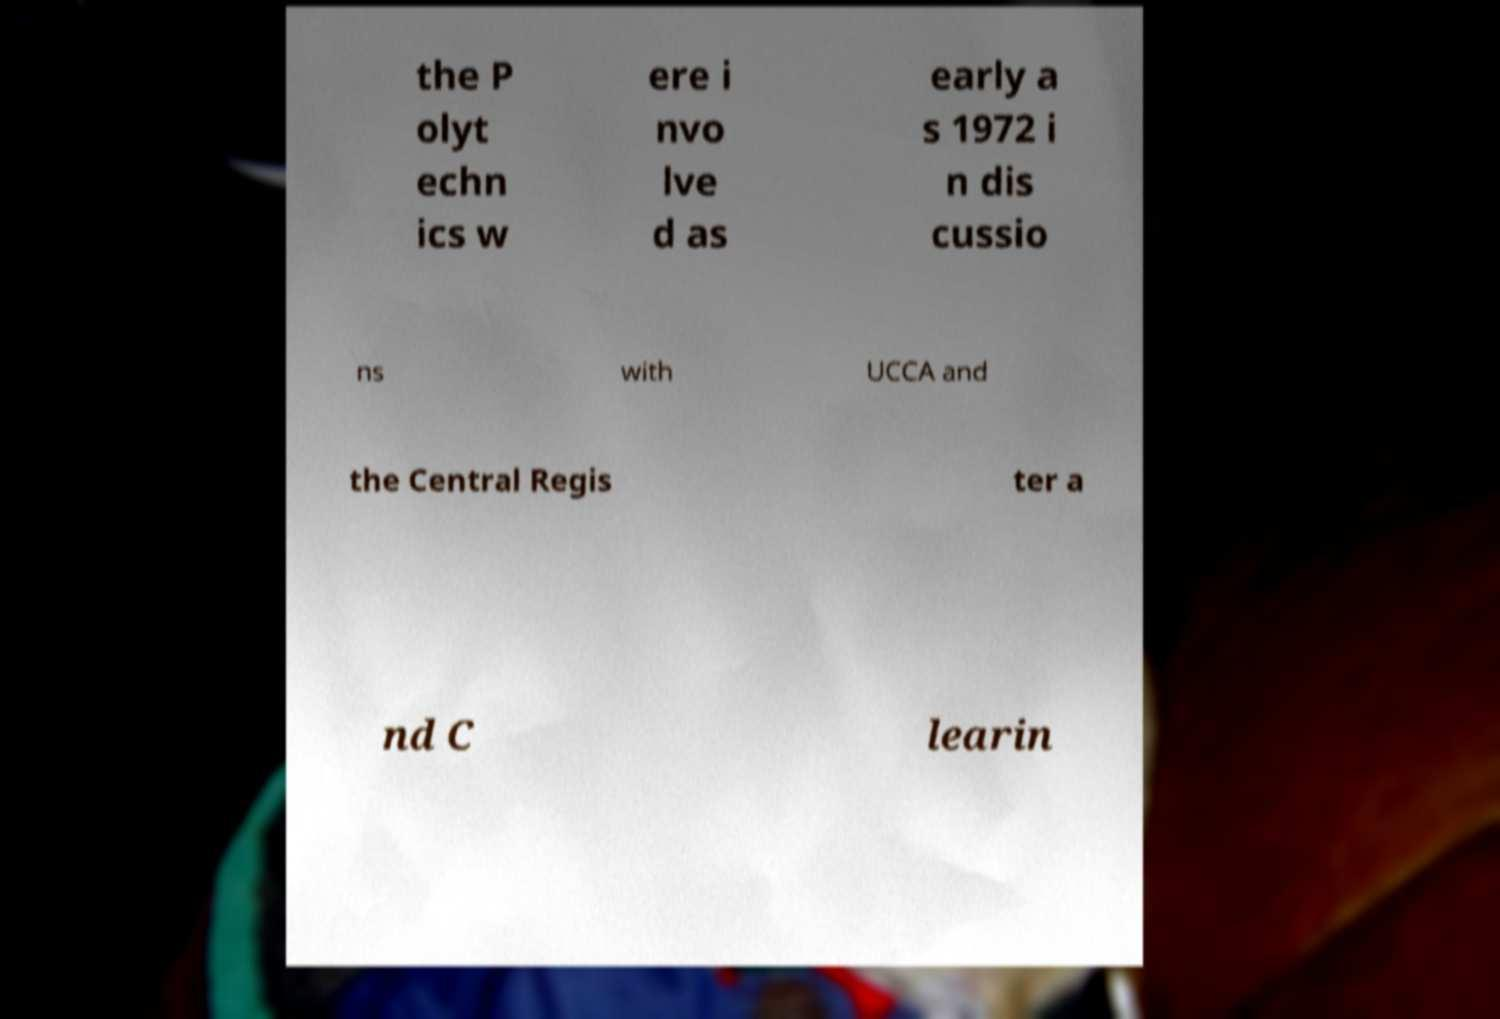Could you extract and type out the text from this image? the P olyt echn ics w ere i nvo lve d as early a s 1972 i n dis cussio ns with UCCA and the Central Regis ter a nd C learin 